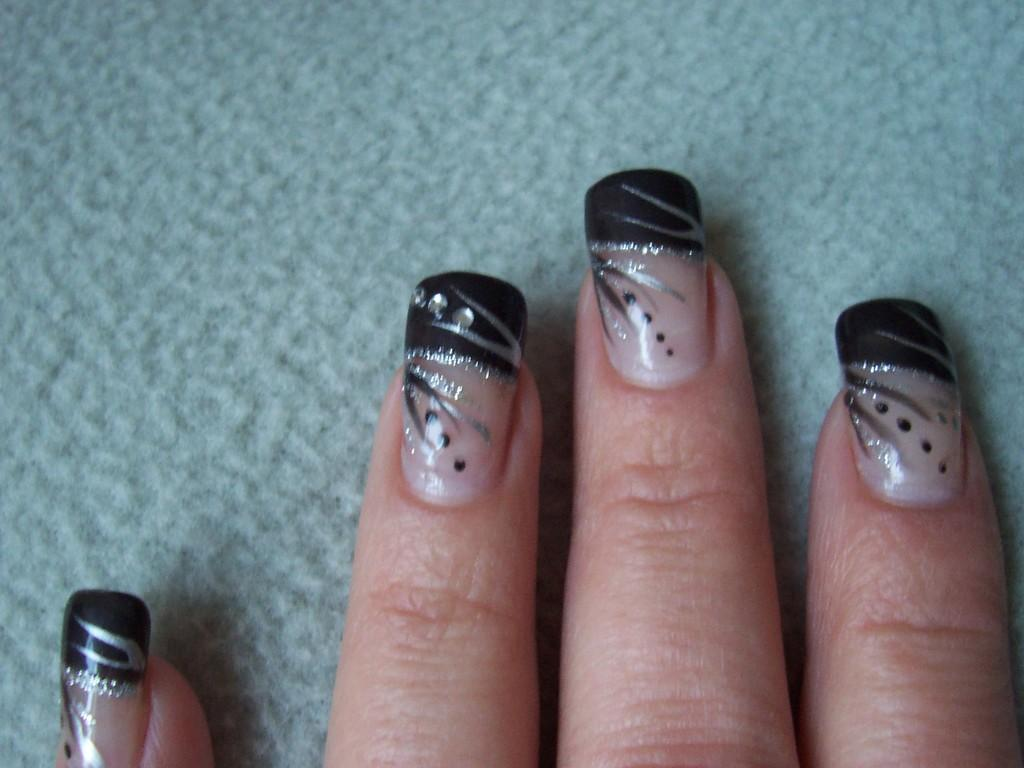What is present in the image? There is a person in the image. What is the person doing in the image? The person's hand is on a surface. What can be seen on the person's nails? Nail polish is visible on the nails. What type of lamp is on the books in the image? There is no lamp or books present in the image; it only features a person with their hand on a surface and nail polish on their nails. 